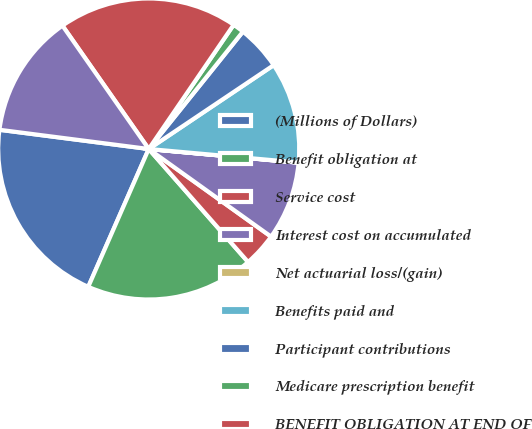<chart> <loc_0><loc_0><loc_500><loc_500><pie_chart><fcel>(Millions of Dollars)<fcel>Benefit obligation at<fcel>Service cost<fcel>Interest cost on accumulated<fcel>Net actuarial loss/(gain)<fcel>Benefits paid and<fcel>Participant contributions<fcel>Medicare prescription benefit<fcel>BENEFIT OBLIGATION AT END OF<fcel>Fair value of plan assets at<nl><fcel>20.46%<fcel>18.06%<fcel>3.63%<fcel>8.44%<fcel>0.02%<fcel>10.84%<fcel>4.83%<fcel>1.22%<fcel>19.26%<fcel>13.25%<nl></chart> 